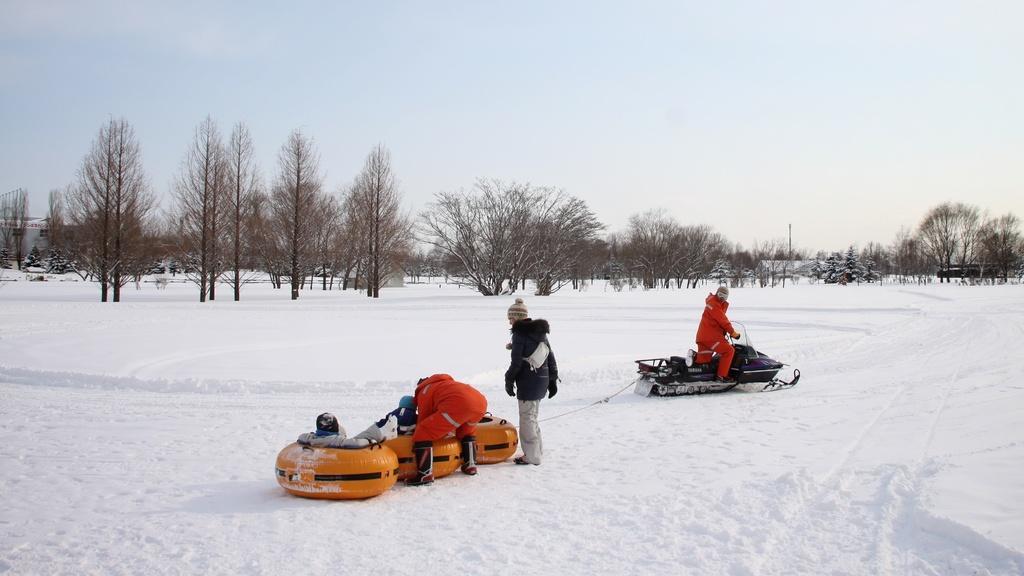In one or two sentences, can you explain what this image depicts? This picture is clicked outside the city. On the right there is a person seems to be sitting on a snow mobile. In the center there are two persons standing on the ground and we can see there are some object placed on the ground. The ground is covered with a lot of snow. In the background there is sky and the trees. 